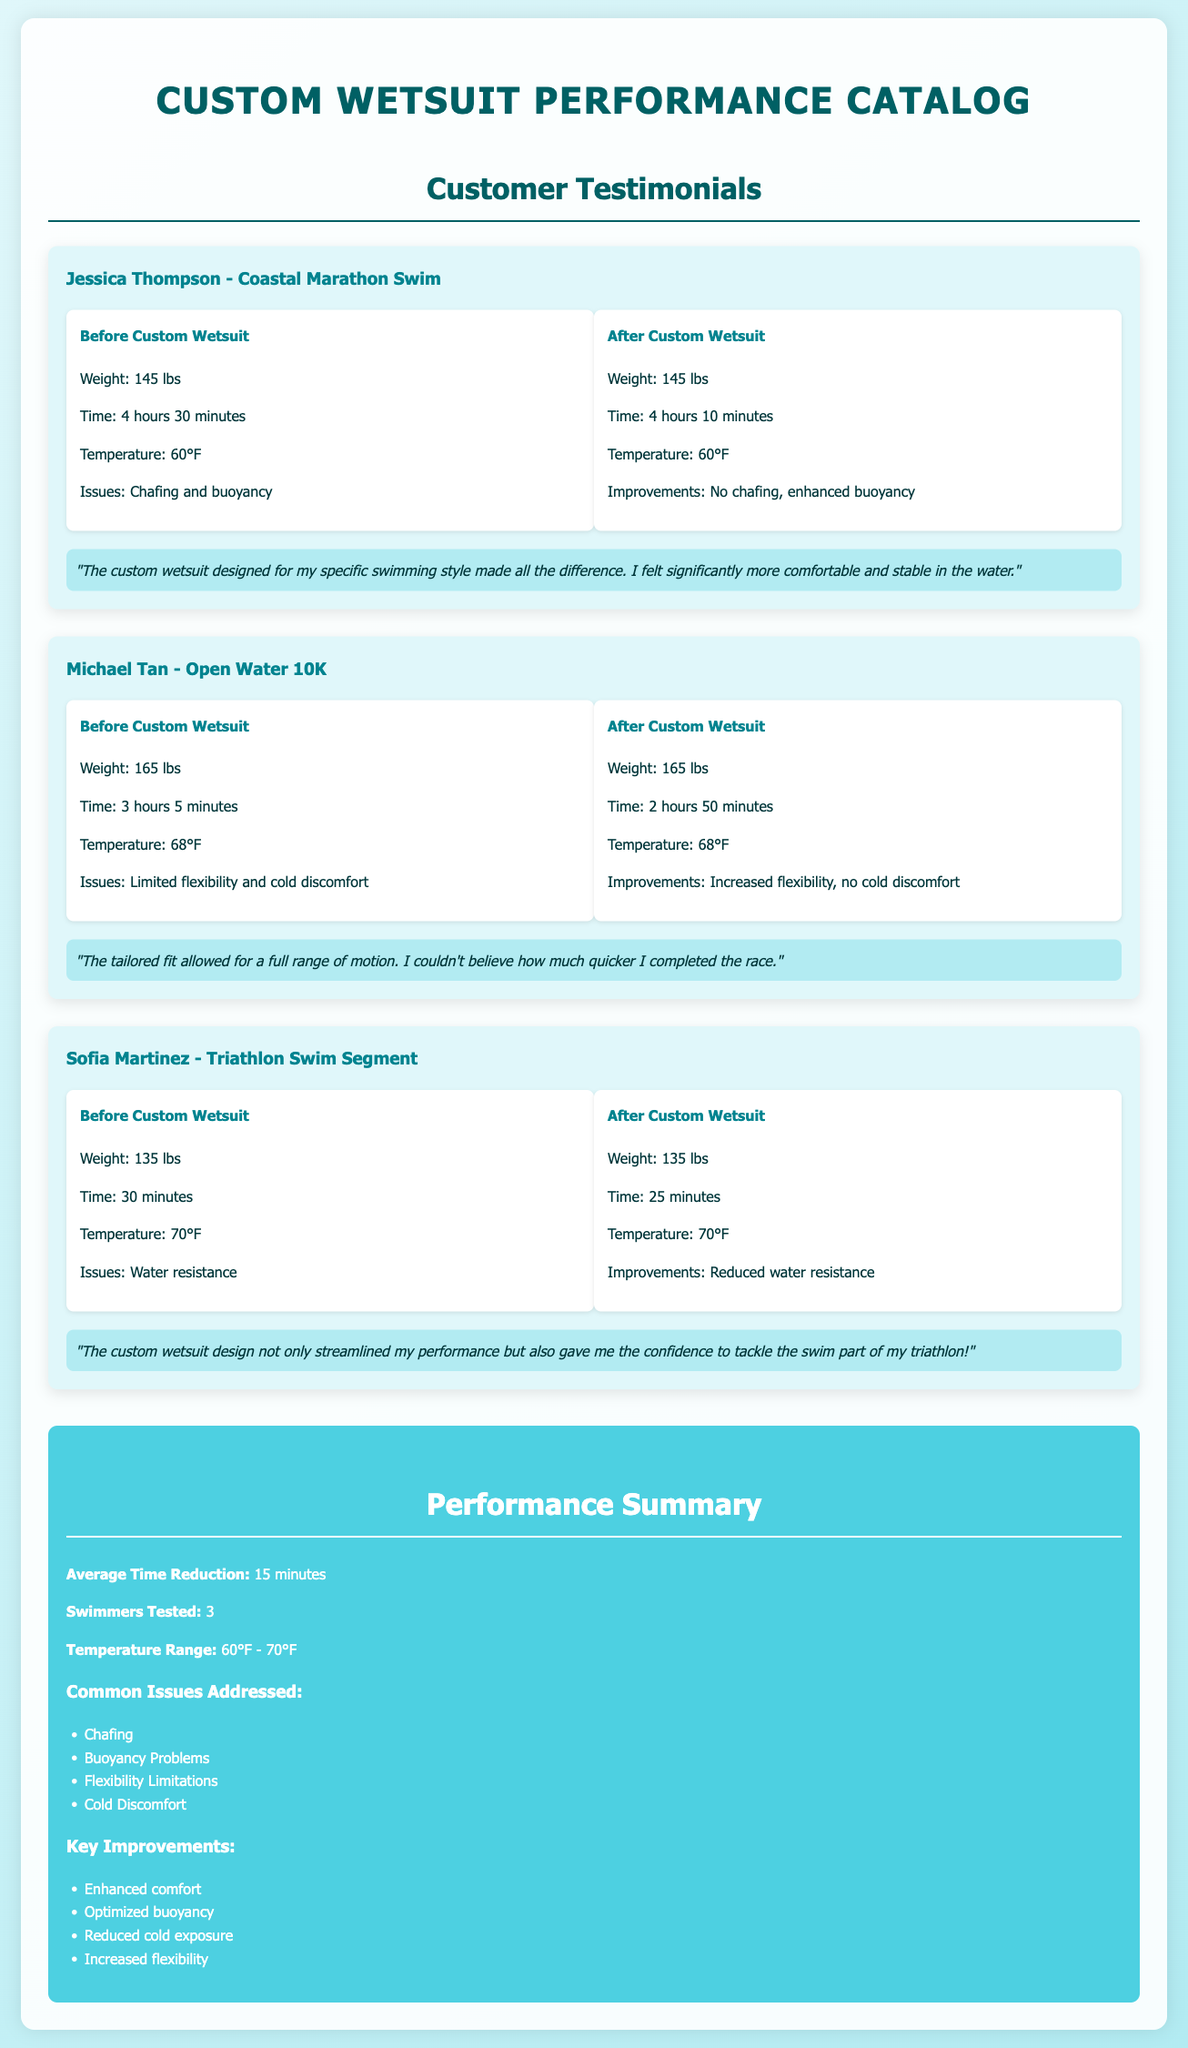What was Jessica Thompson's time before the custom wetsuit? Jessica Thompson's time before the custom wetsuit was one of the specific data points listed in the document, which is 4 hours 30 minutes.
Answer: 4 hours 30 minutes What improvements did Michael Tan notice after using the custom wetsuit? The document specifies the improvements Michael Tan experienced, which were increased flexibility and no cold discomfort.
Answer: Increased flexibility, no cold discomfort How much time did Sofia Martinez reduce from her swim? The difference between her before and after swim times indicates how much time she saved, which is a reduction from 30 minutes to 25 minutes.
Answer: 5 minutes What was the average time reduction across all swimmers? The performance summary section in the document states the average time reduction achieved after using the custom wetsuits is 15 minutes.
Answer: 15 minutes How many swimmers were tested in total? The performance summary confirms that a total of 3 swimmers were tested to gather the performance data in the document.
Answer: 3 What temperature range was tested for the custom wetsuits? The performance summary section provides the temperature range tested, which is between 60°F and 70°F.
Answer: 60°F - 70°F What issue related to comfort was specifically addressed for Jessica Thompson? The document mentions chafing as one of the issues Jessica experienced before using the custom wetsuit.
Answer: Chafing What is the common issue addressed in the custom wetsuit designs? The summary lists several common issues; one notable issue is limited flexibility, which various swimmers faced before custom wetsuit usage.
Answer: Limited flexibility What type of sport did Sofia Martinez participate in? The document states her participation was in a triathlon, specifically focusing on the swim segment.
Answer: Triathlon 